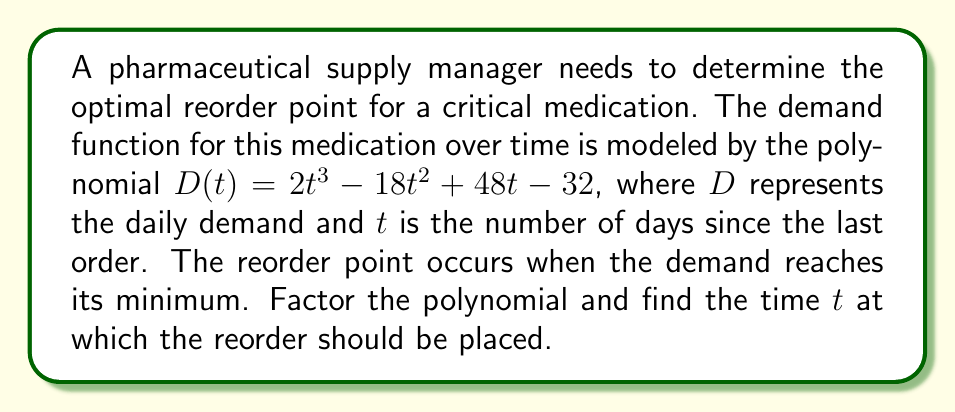Show me your answer to this math problem. To find the optimal reorder point, we need to:

1) Factor the polynomial $D(t) = 2t^3 - 18t^2 + 48t - 32$

2) Find the critical points by setting the derivative equal to zero

3) Determine which critical point gives the minimum demand

Step 1: Factoring the polynomial
$D(t) = 2t^3 - 18t^2 + 48t - 32$
$= 2(t^3 - 9t^2 + 24t - 16)$
$= 2(t - 2)(t^2 - 7t + 8)$
$= 2(t - 2)(t - 4)(t - 3)$

Step 2: Finding critical points
The derivative of $D(t)$ is:
$D'(t) = 2(3t^2 - 18t + 24)$
$= 6(t^2 - 6t + 4)$
$= 6(t - 2)(t - 4)$

Setting $D'(t) = 0$:
$6(t - 2)(t - 4) = 0$
$t = 2$ or $t = 4$

Step 3: Determining the minimum
To find which critical point gives the minimum, we can evaluate $D(t)$ at $t = 2$ and $t = 4$:

$D(2) = 2(2 - 2)(2 - 4)(2 - 3) = 0$
$D(4) = 2(4 - 2)(4 - 4)(4 - 3) = 0$

Since both critical points give the same value, we need to check the behavior of the function around these points. The original polynomial is in the form $2(t - 2)(t - 4)(t - 3)$, which is positive for $t < 2$ and $t > 4$, and negative for $2 < t < 4$.

Therefore, the minimum occurs at $t = 4$, as the function transitions from negative to positive at this point.

The optimal reorder point is thus at $t = 4$ days after the last order.
Answer: 4 days 